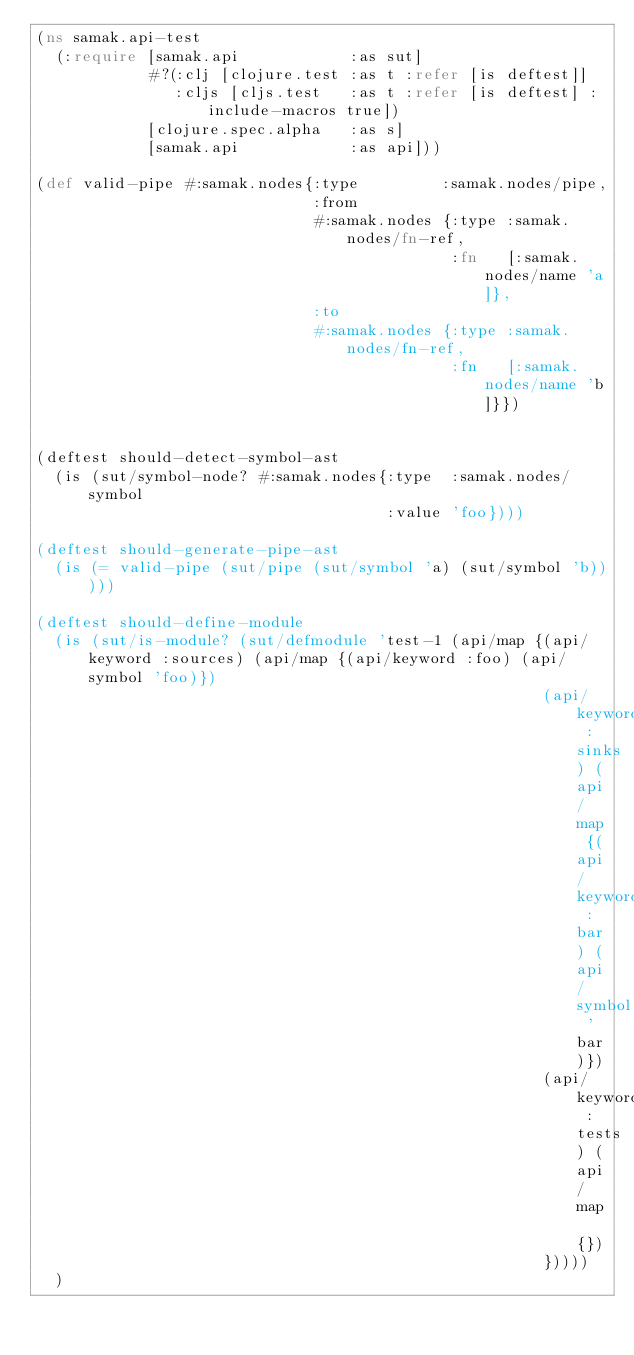Convert code to text. <code><loc_0><loc_0><loc_500><loc_500><_Clojure_>(ns samak.api-test
  (:require [samak.api            :as sut]
            #?(:clj [clojure.test :as t :refer [is deftest]]
               :cljs [cljs.test   :as t :refer [is deftest] :include-macros true])
            [clojure.spec.alpha   :as s]
            [samak.api            :as api]))

(def valid-pipe #:samak.nodes{:type         :samak.nodes/pipe,
                              :from
                              #:samak.nodes {:type :samak.nodes/fn-ref,
                                             :fn   [:samak.nodes/name 'a]},
                              :to
                              #:samak.nodes {:type :samak.nodes/fn-ref,
                                             :fn   [:samak.nodes/name 'b]}})


(deftest should-detect-symbol-ast
  (is (sut/symbol-node? #:samak.nodes{:type  :samak.nodes/symbol
                                      :value 'foo})))

(deftest should-generate-pipe-ast
  (is (= valid-pipe (sut/pipe (sut/symbol 'a) (sut/symbol 'b)))))

(deftest should-define-module
  (is (sut/is-module? (sut/defmodule 'test-1 (api/map {(api/keyword :sources) (api/map {(api/keyword :foo) (api/symbol 'foo)})
                                                       (api/keyword :sinks) (api/map {(api/keyword :bar) (api/symbol 'bar)})
                                                       (api/keyword :tests) (api/map {})
                                                       }))))
  )
</code> 